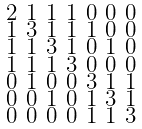Convert formula to latex. <formula><loc_0><loc_0><loc_500><loc_500>\begin{smallmatrix} 2 & 1 & 1 & 1 & 0 & 0 & 0 \\ 1 & 3 & 1 & 1 & 1 & 0 & 0 \\ 1 & 1 & 3 & 1 & 0 & 1 & 0 \\ 1 & 1 & 1 & 3 & 0 & 0 & 0 \\ 0 & 1 & 0 & 0 & 3 & 1 & 1 \\ 0 & 0 & 1 & 0 & 1 & 3 & 1 \\ 0 & 0 & 0 & 0 & 1 & 1 & 3 \end{smallmatrix}</formula> 